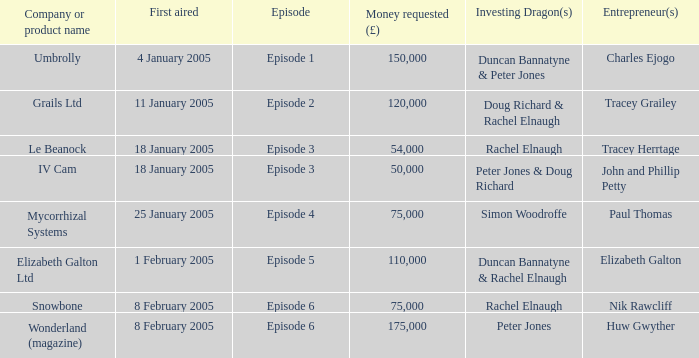What is the average money requested in the episode first aired on 18 January 2005 by the company/product name IV Cam 50000.0. 